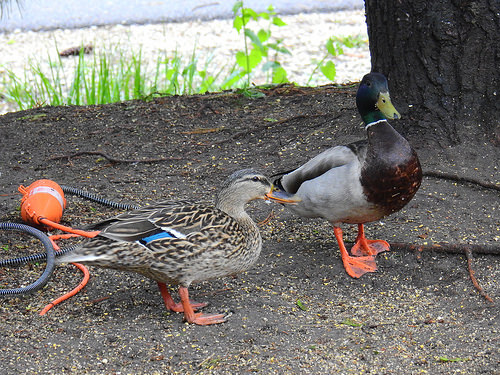<image>
Is there a duck on the plant? No. The duck is not positioned on the plant. They may be near each other, but the duck is not supported by or resting on top of the plant. 